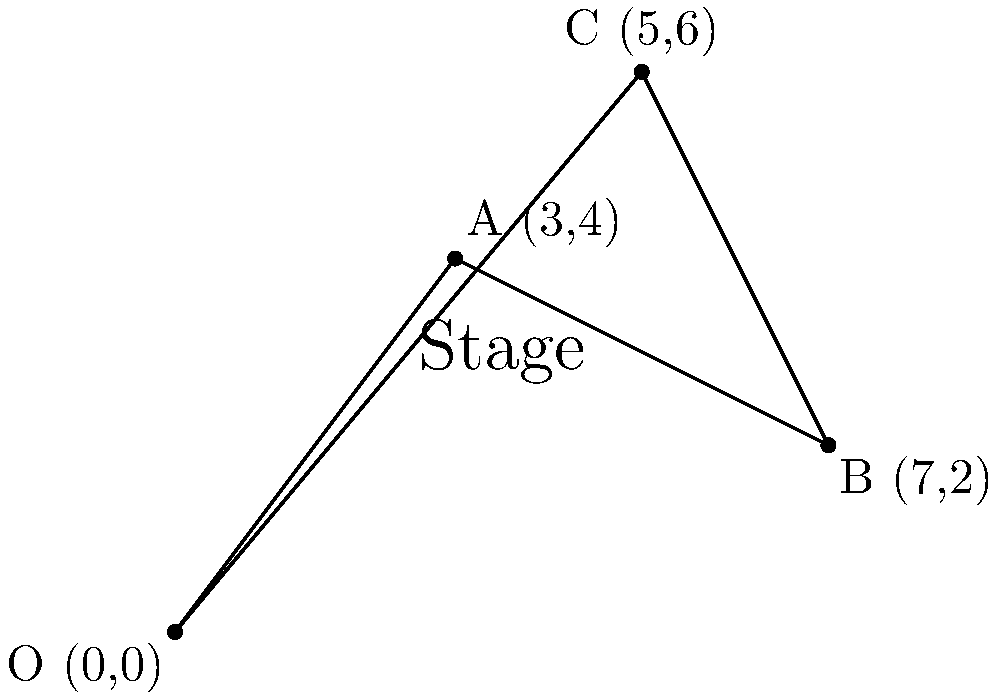For a Star Wars-themed theater production, you need to place three lightsaber props on the stage. The stage is represented by a coordinate system where each unit equals 1 meter. The optimal positions for the lightsabers are at points A(3,4), B(7,2), and C(5,6). Calculate the total distance an actor would need to travel to collect all three lightsabers, starting from the origin O(0,0), visiting each point once, and returning to the origin. Round your answer to the nearest meter. To solve this problem, we need to calculate the distances between each point and sum them up. We'll use the distance formula between two points: $d = \sqrt{(x_2-x_1)^2 + (y_2-y_1)^2}$

1. Distance from O to A:
   $d_{OA} = \sqrt{(3-0)^2 + (4-0)^2} = \sqrt{9 + 16} = \sqrt{25} = 5$ meters

2. Distance from A to B:
   $d_{AB} = \sqrt{(7-3)^2 + (2-4)^2} = \sqrt{16 + 4} = \sqrt{20} = 4.47$ meters

3. Distance from B to C:
   $d_{BC} = \sqrt{(5-7)^2 + (6-2)^2} = \sqrt{4 + 16} = \sqrt{20} = 4.47$ meters

4. Distance from C back to O:
   $d_{CO} = \sqrt{(0-5)^2 + (0-6)^2} = \sqrt{25 + 36} = \sqrt{61} = 7.81$ meters

5. Total distance:
   $d_{total} = d_{OA} + d_{AB} + d_{BC} + d_{CO}$
   $d_{total} = 5 + 4.47 + 4.47 + 7.81 = 21.75$ meters

6. Rounding to the nearest meter:
   $21.75 \approx 22$ meters
Answer: 22 meters 